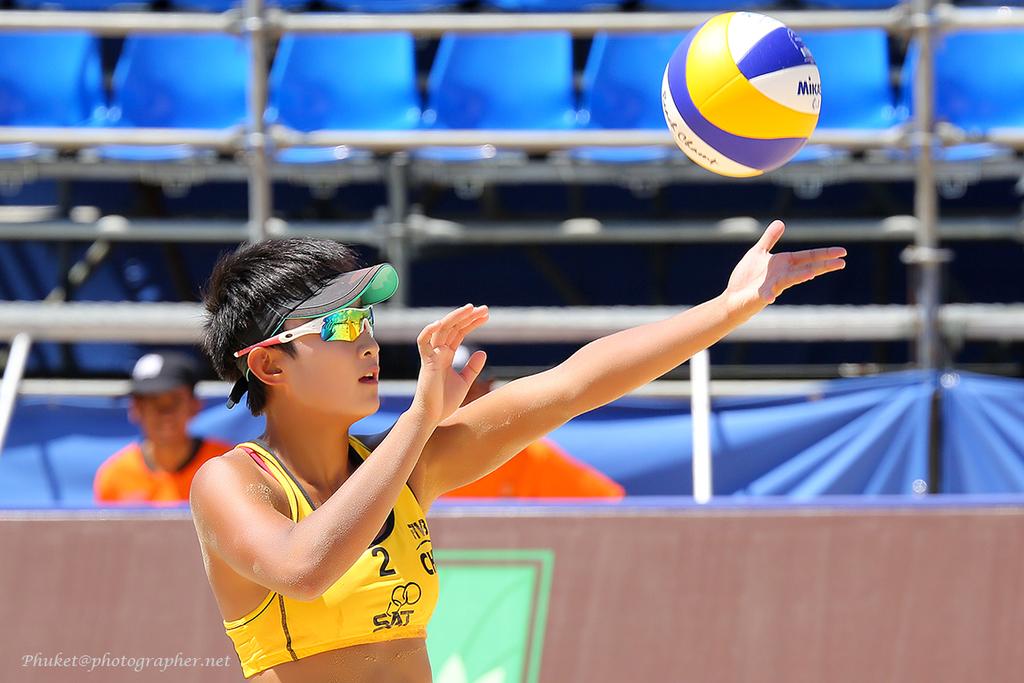What is written on the ball?
Offer a very short reply. Unanswerable. What number is on the players top?
Your response must be concise. 2. 